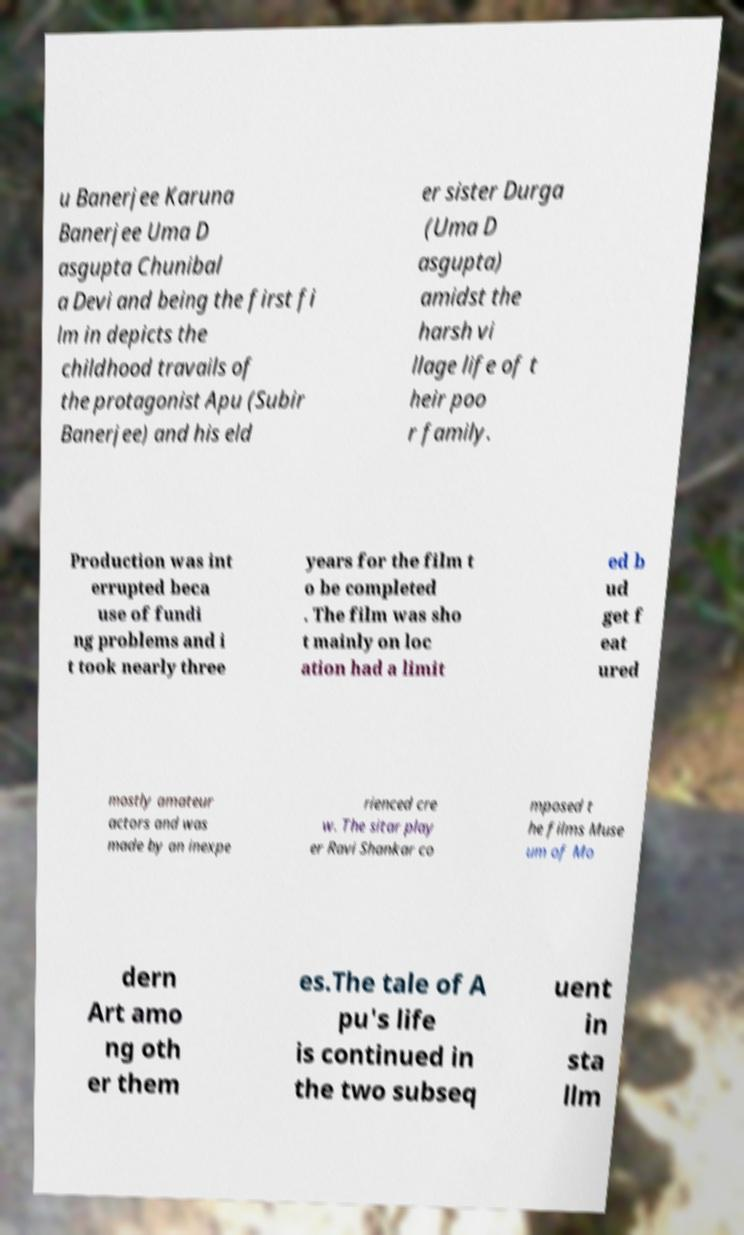Could you extract and type out the text from this image? u Banerjee Karuna Banerjee Uma D asgupta Chunibal a Devi and being the first fi lm in depicts the childhood travails of the protagonist Apu (Subir Banerjee) and his eld er sister Durga (Uma D asgupta) amidst the harsh vi llage life of t heir poo r family. Production was int errupted beca use of fundi ng problems and i t took nearly three years for the film t o be completed . The film was sho t mainly on loc ation had a limit ed b ud get f eat ured mostly amateur actors and was made by an inexpe rienced cre w. The sitar play er Ravi Shankar co mposed t he films Muse um of Mo dern Art amo ng oth er them es.The tale of A pu's life is continued in the two subseq uent in sta llm 